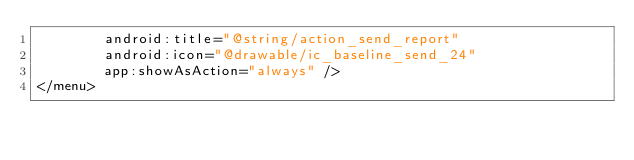<code> <loc_0><loc_0><loc_500><loc_500><_XML_>        android:title="@string/action_send_report"
        android:icon="@drawable/ic_baseline_send_24"
        app:showAsAction="always" />
</menu>
</code> 